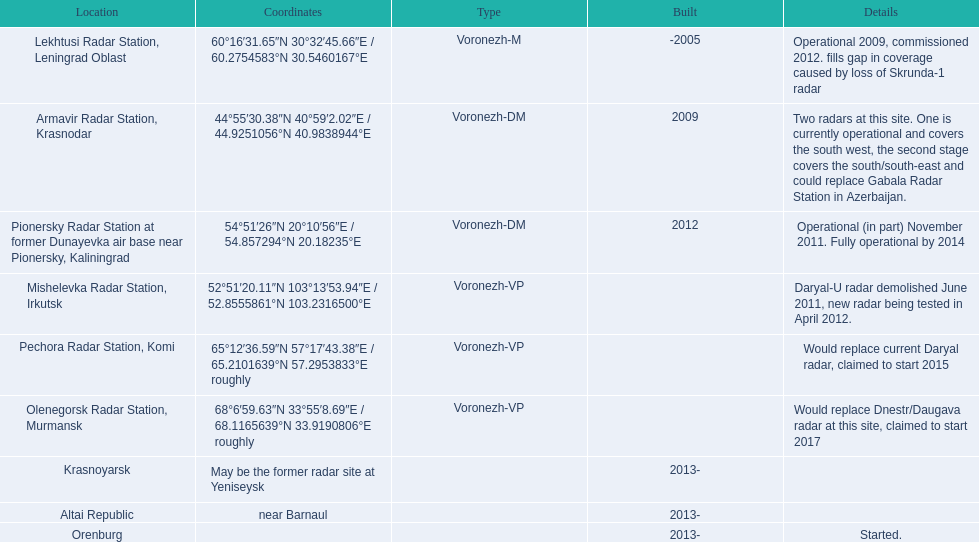In which location can each radar be found? Lekhtusi Radar Station, Leningrad Oblast, Armavir Radar Station, Krasnodar, Pionersky Radar Station at former Dunayevka air base near Pionersky, Kaliningrad, Mishelevka Radar Station, Irkutsk, Pechora Radar Station, Komi, Olenegorsk Radar Station, Murmansk, Krasnoyarsk, Altai Republic, Orenburg. What particulars can you provide about each radar? Operational 2009, commissioned 2012. fills gap in coverage caused by loss of Skrunda-1 radar, Two radars at this site. One is currently operational and covers the south west, the second stage covers the south/south-east and could replace Gabala Radar Station in Azerbaijan., Operational (in part) November 2011. Fully operational by 2014, Daryal-U radar demolished June 2011, new radar being tested in April 2012., Would replace current Daryal radar, claimed to start 2015, Would replace Dnestr/Daugava radar at this site, claimed to start 2017, , , Started. Which radar was scheduled to initiate operations in 2015? Pechora Radar Station, Komi. 